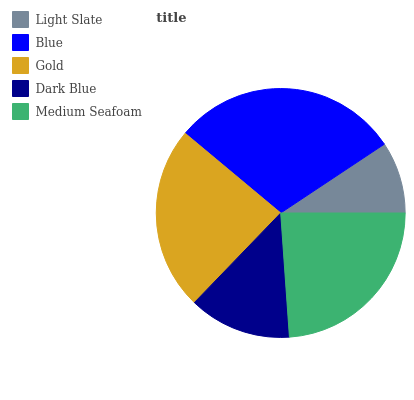Is Light Slate the minimum?
Answer yes or no. Yes. Is Blue the maximum?
Answer yes or no. Yes. Is Gold the minimum?
Answer yes or no. No. Is Gold the maximum?
Answer yes or no. No. Is Blue greater than Gold?
Answer yes or no. Yes. Is Gold less than Blue?
Answer yes or no. Yes. Is Gold greater than Blue?
Answer yes or no. No. Is Blue less than Gold?
Answer yes or no. No. Is Gold the high median?
Answer yes or no. Yes. Is Gold the low median?
Answer yes or no. Yes. Is Dark Blue the high median?
Answer yes or no. No. Is Blue the low median?
Answer yes or no. No. 